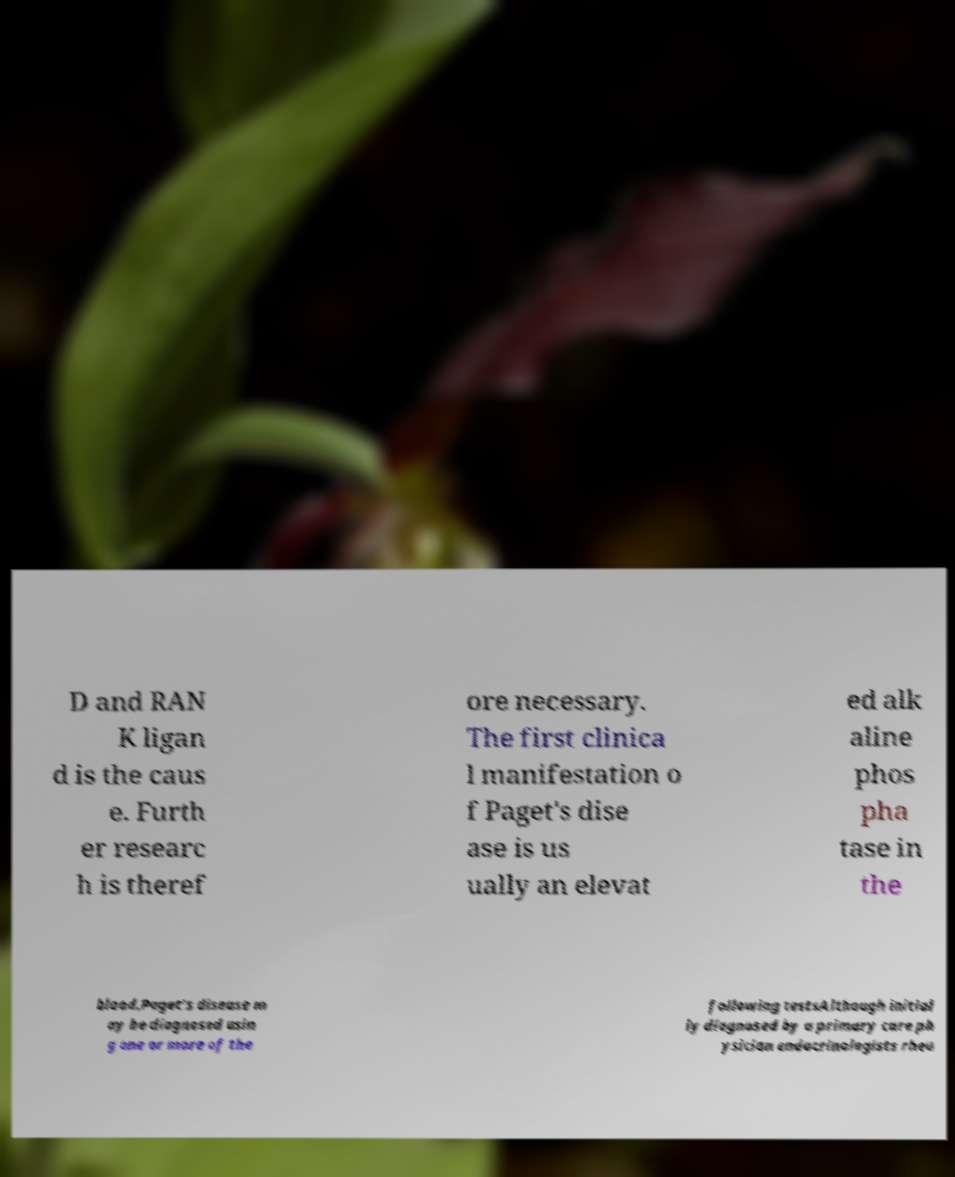Could you assist in decoding the text presented in this image and type it out clearly? D and RAN K ligan d is the caus e. Furth er researc h is theref ore necessary. The first clinica l manifestation o f Paget's dise ase is us ually an elevat ed alk aline phos pha tase in the blood.Paget's disease m ay be diagnosed usin g one or more of the following testsAlthough initial ly diagnosed by a primary care ph ysician endocrinologists rheu 